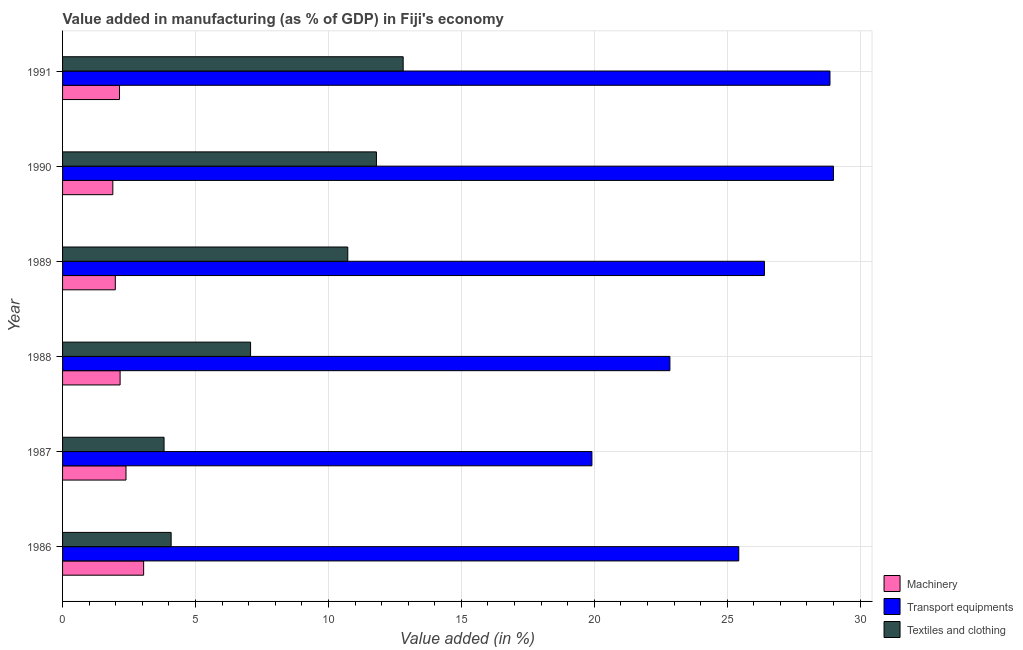Are the number of bars on each tick of the Y-axis equal?
Offer a terse response. Yes. How many bars are there on the 1st tick from the bottom?
Provide a short and direct response. 3. What is the value added in manufacturing transport equipments in 1988?
Your response must be concise. 22.84. Across all years, what is the maximum value added in manufacturing machinery?
Give a very brief answer. 3.05. Across all years, what is the minimum value added in manufacturing textile and clothing?
Ensure brevity in your answer.  3.82. In which year was the value added in manufacturing machinery maximum?
Your answer should be very brief. 1986. What is the total value added in manufacturing transport equipments in the graph?
Your answer should be compact. 152.45. What is the difference between the value added in manufacturing transport equipments in 1987 and that in 1988?
Your response must be concise. -2.93. What is the difference between the value added in manufacturing transport equipments in 1987 and the value added in manufacturing textile and clothing in 1990?
Keep it short and to the point. 8.11. What is the average value added in manufacturing machinery per year?
Your answer should be compact. 2.27. In the year 1987, what is the difference between the value added in manufacturing transport equipments and value added in manufacturing textile and clothing?
Offer a very short reply. 16.09. In how many years, is the value added in manufacturing textile and clothing greater than 3 %?
Give a very brief answer. 6. What is the ratio of the value added in manufacturing machinery in 1986 to that in 1988?
Your answer should be very brief. 1.41. Is the difference between the value added in manufacturing transport equipments in 1988 and 1990 greater than the difference between the value added in manufacturing textile and clothing in 1988 and 1990?
Make the answer very short. No. What is the difference between the highest and the second highest value added in manufacturing machinery?
Ensure brevity in your answer.  0.66. What is the difference between the highest and the lowest value added in manufacturing machinery?
Offer a terse response. 1.16. Is the sum of the value added in manufacturing transport equipments in 1990 and 1991 greater than the maximum value added in manufacturing machinery across all years?
Give a very brief answer. Yes. What does the 2nd bar from the top in 1987 represents?
Make the answer very short. Transport equipments. What does the 3rd bar from the bottom in 1991 represents?
Your answer should be compact. Textiles and clothing. Is it the case that in every year, the sum of the value added in manufacturing machinery and value added in manufacturing transport equipments is greater than the value added in manufacturing textile and clothing?
Your answer should be very brief. Yes. Are all the bars in the graph horizontal?
Give a very brief answer. Yes. How many years are there in the graph?
Keep it short and to the point. 6. Are the values on the major ticks of X-axis written in scientific E-notation?
Offer a terse response. No. Does the graph contain any zero values?
Make the answer very short. No. Does the graph contain grids?
Provide a short and direct response. Yes. Where does the legend appear in the graph?
Make the answer very short. Bottom right. How are the legend labels stacked?
Your answer should be compact. Vertical. What is the title of the graph?
Your response must be concise. Value added in manufacturing (as % of GDP) in Fiji's economy. What is the label or title of the X-axis?
Your response must be concise. Value added (in %). What is the label or title of the Y-axis?
Your response must be concise. Year. What is the Value added (in %) of Machinery in 1986?
Keep it short and to the point. 3.05. What is the Value added (in %) of Transport equipments in 1986?
Offer a terse response. 25.43. What is the Value added (in %) of Textiles and clothing in 1986?
Offer a terse response. 4.08. What is the Value added (in %) of Machinery in 1987?
Your response must be concise. 2.39. What is the Value added (in %) in Transport equipments in 1987?
Ensure brevity in your answer.  19.91. What is the Value added (in %) of Textiles and clothing in 1987?
Your response must be concise. 3.82. What is the Value added (in %) in Machinery in 1988?
Ensure brevity in your answer.  2.16. What is the Value added (in %) in Transport equipments in 1988?
Offer a very short reply. 22.84. What is the Value added (in %) of Textiles and clothing in 1988?
Your answer should be very brief. 7.07. What is the Value added (in %) in Machinery in 1989?
Offer a very short reply. 1.98. What is the Value added (in %) of Transport equipments in 1989?
Provide a succinct answer. 26.4. What is the Value added (in %) in Textiles and clothing in 1989?
Ensure brevity in your answer.  10.73. What is the Value added (in %) of Machinery in 1990?
Your answer should be very brief. 1.89. What is the Value added (in %) in Transport equipments in 1990?
Your answer should be very brief. 29. What is the Value added (in %) in Textiles and clothing in 1990?
Offer a very short reply. 11.81. What is the Value added (in %) in Machinery in 1991?
Your answer should be compact. 2.14. What is the Value added (in %) in Transport equipments in 1991?
Offer a very short reply. 28.86. What is the Value added (in %) in Textiles and clothing in 1991?
Offer a terse response. 12.81. Across all years, what is the maximum Value added (in %) in Machinery?
Provide a succinct answer. 3.05. Across all years, what is the maximum Value added (in %) in Transport equipments?
Make the answer very short. 29. Across all years, what is the maximum Value added (in %) of Textiles and clothing?
Your response must be concise. 12.81. Across all years, what is the minimum Value added (in %) of Machinery?
Provide a succinct answer. 1.89. Across all years, what is the minimum Value added (in %) in Transport equipments?
Your response must be concise. 19.91. Across all years, what is the minimum Value added (in %) of Textiles and clothing?
Your response must be concise. 3.82. What is the total Value added (in %) in Machinery in the graph?
Ensure brevity in your answer.  13.62. What is the total Value added (in %) of Transport equipments in the graph?
Make the answer very short. 152.45. What is the total Value added (in %) in Textiles and clothing in the graph?
Your answer should be very brief. 50.32. What is the difference between the Value added (in %) of Machinery in 1986 and that in 1987?
Provide a succinct answer. 0.66. What is the difference between the Value added (in %) of Transport equipments in 1986 and that in 1987?
Your answer should be compact. 5.52. What is the difference between the Value added (in %) of Textiles and clothing in 1986 and that in 1987?
Keep it short and to the point. 0.27. What is the difference between the Value added (in %) in Machinery in 1986 and that in 1988?
Make the answer very short. 0.89. What is the difference between the Value added (in %) in Transport equipments in 1986 and that in 1988?
Offer a very short reply. 2.59. What is the difference between the Value added (in %) in Textiles and clothing in 1986 and that in 1988?
Provide a short and direct response. -2.99. What is the difference between the Value added (in %) of Machinery in 1986 and that in 1989?
Offer a very short reply. 1.07. What is the difference between the Value added (in %) of Transport equipments in 1986 and that in 1989?
Offer a very short reply. -0.97. What is the difference between the Value added (in %) in Textiles and clothing in 1986 and that in 1989?
Give a very brief answer. -6.64. What is the difference between the Value added (in %) in Machinery in 1986 and that in 1990?
Ensure brevity in your answer.  1.16. What is the difference between the Value added (in %) in Transport equipments in 1986 and that in 1990?
Provide a succinct answer. -3.56. What is the difference between the Value added (in %) in Textiles and clothing in 1986 and that in 1990?
Offer a terse response. -7.72. What is the difference between the Value added (in %) in Machinery in 1986 and that in 1991?
Offer a terse response. 0.91. What is the difference between the Value added (in %) of Transport equipments in 1986 and that in 1991?
Your response must be concise. -3.43. What is the difference between the Value added (in %) in Textiles and clothing in 1986 and that in 1991?
Ensure brevity in your answer.  -8.73. What is the difference between the Value added (in %) of Machinery in 1987 and that in 1988?
Your response must be concise. 0.22. What is the difference between the Value added (in %) of Transport equipments in 1987 and that in 1988?
Give a very brief answer. -2.93. What is the difference between the Value added (in %) in Textiles and clothing in 1987 and that in 1988?
Ensure brevity in your answer.  -3.25. What is the difference between the Value added (in %) in Machinery in 1987 and that in 1989?
Offer a very short reply. 0.4. What is the difference between the Value added (in %) of Transport equipments in 1987 and that in 1989?
Give a very brief answer. -6.49. What is the difference between the Value added (in %) of Textiles and clothing in 1987 and that in 1989?
Your answer should be compact. -6.91. What is the difference between the Value added (in %) in Machinery in 1987 and that in 1990?
Provide a short and direct response. 0.5. What is the difference between the Value added (in %) in Transport equipments in 1987 and that in 1990?
Offer a very short reply. -9.09. What is the difference between the Value added (in %) in Textiles and clothing in 1987 and that in 1990?
Make the answer very short. -7.99. What is the difference between the Value added (in %) of Machinery in 1987 and that in 1991?
Give a very brief answer. 0.24. What is the difference between the Value added (in %) in Transport equipments in 1987 and that in 1991?
Your response must be concise. -8.95. What is the difference between the Value added (in %) of Textiles and clothing in 1987 and that in 1991?
Ensure brevity in your answer.  -8.99. What is the difference between the Value added (in %) in Machinery in 1988 and that in 1989?
Keep it short and to the point. 0.18. What is the difference between the Value added (in %) of Transport equipments in 1988 and that in 1989?
Your answer should be very brief. -3.56. What is the difference between the Value added (in %) in Textiles and clothing in 1988 and that in 1989?
Keep it short and to the point. -3.66. What is the difference between the Value added (in %) in Machinery in 1988 and that in 1990?
Keep it short and to the point. 0.27. What is the difference between the Value added (in %) in Transport equipments in 1988 and that in 1990?
Provide a succinct answer. -6.15. What is the difference between the Value added (in %) in Textiles and clothing in 1988 and that in 1990?
Your response must be concise. -4.73. What is the difference between the Value added (in %) of Machinery in 1988 and that in 1991?
Ensure brevity in your answer.  0.02. What is the difference between the Value added (in %) of Transport equipments in 1988 and that in 1991?
Provide a succinct answer. -6.02. What is the difference between the Value added (in %) of Textiles and clothing in 1988 and that in 1991?
Your response must be concise. -5.74. What is the difference between the Value added (in %) in Machinery in 1989 and that in 1990?
Ensure brevity in your answer.  0.09. What is the difference between the Value added (in %) in Transport equipments in 1989 and that in 1990?
Make the answer very short. -2.6. What is the difference between the Value added (in %) of Textiles and clothing in 1989 and that in 1990?
Give a very brief answer. -1.08. What is the difference between the Value added (in %) in Machinery in 1989 and that in 1991?
Offer a very short reply. -0.16. What is the difference between the Value added (in %) of Transport equipments in 1989 and that in 1991?
Ensure brevity in your answer.  -2.46. What is the difference between the Value added (in %) of Textiles and clothing in 1989 and that in 1991?
Provide a succinct answer. -2.08. What is the difference between the Value added (in %) of Machinery in 1990 and that in 1991?
Give a very brief answer. -0.25. What is the difference between the Value added (in %) of Transport equipments in 1990 and that in 1991?
Make the answer very short. 0.13. What is the difference between the Value added (in %) in Textiles and clothing in 1990 and that in 1991?
Ensure brevity in your answer.  -1.01. What is the difference between the Value added (in %) in Machinery in 1986 and the Value added (in %) in Transport equipments in 1987?
Offer a terse response. -16.86. What is the difference between the Value added (in %) of Machinery in 1986 and the Value added (in %) of Textiles and clothing in 1987?
Your response must be concise. -0.77. What is the difference between the Value added (in %) of Transport equipments in 1986 and the Value added (in %) of Textiles and clothing in 1987?
Offer a terse response. 21.62. What is the difference between the Value added (in %) in Machinery in 1986 and the Value added (in %) in Transport equipments in 1988?
Offer a very short reply. -19.79. What is the difference between the Value added (in %) in Machinery in 1986 and the Value added (in %) in Textiles and clothing in 1988?
Offer a terse response. -4.02. What is the difference between the Value added (in %) in Transport equipments in 1986 and the Value added (in %) in Textiles and clothing in 1988?
Give a very brief answer. 18.36. What is the difference between the Value added (in %) of Machinery in 1986 and the Value added (in %) of Transport equipments in 1989?
Your answer should be very brief. -23.35. What is the difference between the Value added (in %) of Machinery in 1986 and the Value added (in %) of Textiles and clothing in 1989?
Give a very brief answer. -7.68. What is the difference between the Value added (in %) in Transport equipments in 1986 and the Value added (in %) in Textiles and clothing in 1989?
Offer a terse response. 14.71. What is the difference between the Value added (in %) in Machinery in 1986 and the Value added (in %) in Transport equipments in 1990?
Your answer should be very brief. -25.95. What is the difference between the Value added (in %) of Machinery in 1986 and the Value added (in %) of Textiles and clothing in 1990?
Offer a terse response. -8.76. What is the difference between the Value added (in %) in Transport equipments in 1986 and the Value added (in %) in Textiles and clothing in 1990?
Offer a very short reply. 13.63. What is the difference between the Value added (in %) of Machinery in 1986 and the Value added (in %) of Transport equipments in 1991?
Provide a succinct answer. -25.82. What is the difference between the Value added (in %) in Machinery in 1986 and the Value added (in %) in Textiles and clothing in 1991?
Ensure brevity in your answer.  -9.76. What is the difference between the Value added (in %) of Transport equipments in 1986 and the Value added (in %) of Textiles and clothing in 1991?
Give a very brief answer. 12.62. What is the difference between the Value added (in %) in Machinery in 1987 and the Value added (in %) in Transport equipments in 1988?
Make the answer very short. -20.46. What is the difference between the Value added (in %) of Machinery in 1987 and the Value added (in %) of Textiles and clothing in 1988?
Make the answer very short. -4.69. What is the difference between the Value added (in %) of Transport equipments in 1987 and the Value added (in %) of Textiles and clothing in 1988?
Provide a short and direct response. 12.84. What is the difference between the Value added (in %) of Machinery in 1987 and the Value added (in %) of Transport equipments in 1989?
Make the answer very short. -24.01. What is the difference between the Value added (in %) of Machinery in 1987 and the Value added (in %) of Textiles and clothing in 1989?
Give a very brief answer. -8.34. What is the difference between the Value added (in %) in Transport equipments in 1987 and the Value added (in %) in Textiles and clothing in 1989?
Ensure brevity in your answer.  9.18. What is the difference between the Value added (in %) of Machinery in 1987 and the Value added (in %) of Transport equipments in 1990?
Offer a terse response. -26.61. What is the difference between the Value added (in %) of Machinery in 1987 and the Value added (in %) of Textiles and clothing in 1990?
Offer a terse response. -9.42. What is the difference between the Value added (in %) of Transport equipments in 1987 and the Value added (in %) of Textiles and clothing in 1990?
Ensure brevity in your answer.  8.11. What is the difference between the Value added (in %) of Machinery in 1987 and the Value added (in %) of Transport equipments in 1991?
Offer a very short reply. -26.48. What is the difference between the Value added (in %) of Machinery in 1987 and the Value added (in %) of Textiles and clothing in 1991?
Provide a short and direct response. -10.43. What is the difference between the Value added (in %) of Transport equipments in 1987 and the Value added (in %) of Textiles and clothing in 1991?
Your answer should be compact. 7.1. What is the difference between the Value added (in %) of Machinery in 1988 and the Value added (in %) of Transport equipments in 1989?
Your response must be concise. -24.24. What is the difference between the Value added (in %) in Machinery in 1988 and the Value added (in %) in Textiles and clothing in 1989?
Offer a terse response. -8.56. What is the difference between the Value added (in %) of Transport equipments in 1988 and the Value added (in %) of Textiles and clothing in 1989?
Offer a very short reply. 12.12. What is the difference between the Value added (in %) of Machinery in 1988 and the Value added (in %) of Transport equipments in 1990?
Ensure brevity in your answer.  -26.83. What is the difference between the Value added (in %) in Machinery in 1988 and the Value added (in %) in Textiles and clothing in 1990?
Ensure brevity in your answer.  -9.64. What is the difference between the Value added (in %) in Transport equipments in 1988 and the Value added (in %) in Textiles and clothing in 1990?
Give a very brief answer. 11.04. What is the difference between the Value added (in %) in Machinery in 1988 and the Value added (in %) in Transport equipments in 1991?
Make the answer very short. -26.7. What is the difference between the Value added (in %) in Machinery in 1988 and the Value added (in %) in Textiles and clothing in 1991?
Provide a succinct answer. -10.65. What is the difference between the Value added (in %) in Transport equipments in 1988 and the Value added (in %) in Textiles and clothing in 1991?
Offer a terse response. 10.03. What is the difference between the Value added (in %) of Machinery in 1989 and the Value added (in %) of Transport equipments in 1990?
Provide a short and direct response. -27.01. What is the difference between the Value added (in %) in Machinery in 1989 and the Value added (in %) in Textiles and clothing in 1990?
Make the answer very short. -9.82. What is the difference between the Value added (in %) of Transport equipments in 1989 and the Value added (in %) of Textiles and clothing in 1990?
Ensure brevity in your answer.  14.59. What is the difference between the Value added (in %) of Machinery in 1989 and the Value added (in %) of Transport equipments in 1991?
Provide a short and direct response. -26.88. What is the difference between the Value added (in %) of Machinery in 1989 and the Value added (in %) of Textiles and clothing in 1991?
Provide a succinct answer. -10.83. What is the difference between the Value added (in %) in Transport equipments in 1989 and the Value added (in %) in Textiles and clothing in 1991?
Your answer should be compact. 13.59. What is the difference between the Value added (in %) of Machinery in 1990 and the Value added (in %) of Transport equipments in 1991?
Your answer should be very brief. -26.97. What is the difference between the Value added (in %) in Machinery in 1990 and the Value added (in %) in Textiles and clothing in 1991?
Your response must be concise. -10.92. What is the difference between the Value added (in %) in Transport equipments in 1990 and the Value added (in %) in Textiles and clothing in 1991?
Your answer should be compact. 16.19. What is the average Value added (in %) of Machinery per year?
Offer a very short reply. 2.27. What is the average Value added (in %) in Transport equipments per year?
Offer a very short reply. 25.41. What is the average Value added (in %) of Textiles and clothing per year?
Make the answer very short. 8.39. In the year 1986, what is the difference between the Value added (in %) of Machinery and Value added (in %) of Transport equipments?
Your response must be concise. -22.38. In the year 1986, what is the difference between the Value added (in %) in Machinery and Value added (in %) in Textiles and clothing?
Provide a short and direct response. -1.03. In the year 1986, what is the difference between the Value added (in %) in Transport equipments and Value added (in %) in Textiles and clothing?
Ensure brevity in your answer.  21.35. In the year 1987, what is the difference between the Value added (in %) in Machinery and Value added (in %) in Transport equipments?
Provide a succinct answer. -17.53. In the year 1987, what is the difference between the Value added (in %) of Machinery and Value added (in %) of Textiles and clothing?
Your response must be concise. -1.43. In the year 1987, what is the difference between the Value added (in %) in Transport equipments and Value added (in %) in Textiles and clothing?
Your response must be concise. 16.09. In the year 1988, what is the difference between the Value added (in %) of Machinery and Value added (in %) of Transport equipments?
Provide a short and direct response. -20.68. In the year 1988, what is the difference between the Value added (in %) of Machinery and Value added (in %) of Textiles and clothing?
Offer a terse response. -4.91. In the year 1988, what is the difference between the Value added (in %) of Transport equipments and Value added (in %) of Textiles and clothing?
Give a very brief answer. 15.77. In the year 1989, what is the difference between the Value added (in %) in Machinery and Value added (in %) in Transport equipments?
Give a very brief answer. -24.42. In the year 1989, what is the difference between the Value added (in %) of Machinery and Value added (in %) of Textiles and clothing?
Your answer should be compact. -8.74. In the year 1989, what is the difference between the Value added (in %) in Transport equipments and Value added (in %) in Textiles and clothing?
Provide a succinct answer. 15.67. In the year 1990, what is the difference between the Value added (in %) of Machinery and Value added (in %) of Transport equipments?
Provide a succinct answer. -27.11. In the year 1990, what is the difference between the Value added (in %) of Machinery and Value added (in %) of Textiles and clothing?
Provide a short and direct response. -9.92. In the year 1990, what is the difference between the Value added (in %) in Transport equipments and Value added (in %) in Textiles and clothing?
Provide a short and direct response. 17.19. In the year 1991, what is the difference between the Value added (in %) of Machinery and Value added (in %) of Transport equipments?
Provide a short and direct response. -26.72. In the year 1991, what is the difference between the Value added (in %) of Machinery and Value added (in %) of Textiles and clothing?
Offer a very short reply. -10.67. In the year 1991, what is the difference between the Value added (in %) in Transport equipments and Value added (in %) in Textiles and clothing?
Offer a very short reply. 16.05. What is the ratio of the Value added (in %) in Machinery in 1986 to that in 1987?
Give a very brief answer. 1.28. What is the ratio of the Value added (in %) of Transport equipments in 1986 to that in 1987?
Your response must be concise. 1.28. What is the ratio of the Value added (in %) of Textiles and clothing in 1986 to that in 1987?
Provide a short and direct response. 1.07. What is the ratio of the Value added (in %) in Machinery in 1986 to that in 1988?
Your answer should be compact. 1.41. What is the ratio of the Value added (in %) in Transport equipments in 1986 to that in 1988?
Your response must be concise. 1.11. What is the ratio of the Value added (in %) in Textiles and clothing in 1986 to that in 1988?
Make the answer very short. 0.58. What is the ratio of the Value added (in %) in Machinery in 1986 to that in 1989?
Your answer should be compact. 1.54. What is the ratio of the Value added (in %) in Transport equipments in 1986 to that in 1989?
Provide a succinct answer. 0.96. What is the ratio of the Value added (in %) in Textiles and clothing in 1986 to that in 1989?
Provide a short and direct response. 0.38. What is the ratio of the Value added (in %) in Machinery in 1986 to that in 1990?
Give a very brief answer. 1.61. What is the ratio of the Value added (in %) of Transport equipments in 1986 to that in 1990?
Offer a terse response. 0.88. What is the ratio of the Value added (in %) in Textiles and clothing in 1986 to that in 1990?
Ensure brevity in your answer.  0.35. What is the ratio of the Value added (in %) in Machinery in 1986 to that in 1991?
Give a very brief answer. 1.42. What is the ratio of the Value added (in %) in Transport equipments in 1986 to that in 1991?
Your answer should be compact. 0.88. What is the ratio of the Value added (in %) of Textiles and clothing in 1986 to that in 1991?
Your answer should be compact. 0.32. What is the ratio of the Value added (in %) in Machinery in 1987 to that in 1988?
Your answer should be compact. 1.1. What is the ratio of the Value added (in %) of Transport equipments in 1987 to that in 1988?
Make the answer very short. 0.87. What is the ratio of the Value added (in %) in Textiles and clothing in 1987 to that in 1988?
Offer a very short reply. 0.54. What is the ratio of the Value added (in %) in Machinery in 1987 to that in 1989?
Your response must be concise. 1.2. What is the ratio of the Value added (in %) of Transport equipments in 1987 to that in 1989?
Provide a short and direct response. 0.75. What is the ratio of the Value added (in %) in Textiles and clothing in 1987 to that in 1989?
Provide a short and direct response. 0.36. What is the ratio of the Value added (in %) in Machinery in 1987 to that in 1990?
Keep it short and to the point. 1.26. What is the ratio of the Value added (in %) in Transport equipments in 1987 to that in 1990?
Ensure brevity in your answer.  0.69. What is the ratio of the Value added (in %) in Textiles and clothing in 1987 to that in 1990?
Your answer should be compact. 0.32. What is the ratio of the Value added (in %) in Machinery in 1987 to that in 1991?
Keep it short and to the point. 1.11. What is the ratio of the Value added (in %) of Transport equipments in 1987 to that in 1991?
Your answer should be very brief. 0.69. What is the ratio of the Value added (in %) of Textiles and clothing in 1987 to that in 1991?
Give a very brief answer. 0.3. What is the ratio of the Value added (in %) in Machinery in 1988 to that in 1989?
Offer a terse response. 1.09. What is the ratio of the Value added (in %) of Transport equipments in 1988 to that in 1989?
Offer a terse response. 0.87. What is the ratio of the Value added (in %) of Textiles and clothing in 1988 to that in 1989?
Give a very brief answer. 0.66. What is the ratio of the Value added (in %) in Machinery in 1988 to that in 1990?
Give a very brief answer. 1.14. What is the ratio of the Value added (in %) of Transport equipments in 1988 to that in 1990?
Offer a very short reply. 0.79. What is the ratio of the Value added (in %) in Textiles and clothing in 1988 to that in 1990?
Your answer should be compact. 0.6. What is the ratio of the Value added (in %) in Machinery in 1988 to that in 1991?
Keep it short and to the point. 1.01. What is the ratio of the Value added (in %) in Transport equipments in 1988 to that in 1991?
Ensure brevity in your answer.  0.79. What is the ratio of the Value added (in %) of Textiles and clothing in 1988 to that in 1991?
Keep it short and to the point. 0.55. What is the ratio of the Value added (in %) of Machinery in 1989 to that in 1990?
Your response must be concise. 1.05. What is the ratio of the Value added (in %) of Transport equipments in 1989 to that in 1990?
Make the answer very short. 0.91. What is the ratio of the Value added (in %) in Textiles and clothing in 1989 to that in 1990?
Provide a short and direct response. 0.91. What is the ratio of the Value added (in %) of Machinery in 1989 to that in 1991?
Ensure brevity in your answer.  0.93. What is the ratio of the Value added (in %) in Transport equipments in 1989 to that in 1991?
Give a very brief answer. 0.91. What is the ratio of the Value added (in %) in Textiles and clothing in 1989 to that in 1991?
Keep it short and to the point. 0.84. What is the ratio of the Value added (in %) of Machinery in 1990 to that in 1991?
Keep it short and to the point. 0.88. What is the ratio of the Value added (in %) in Textiles and clothing in 1990 to that in 1991?
Provide a succinct answer. 0.92. What is the difference between the highest and the second highest Value added (in %) of Machinery?
Offer a terse response. 0.66. What is the difference between the highest and the second highest Value added (in %) in Transport equipments?
Give a very brief answer. 0.13. What is the difference between the highest and the lowest Value added (in %) of Machinery?
Ensure brevity in your answer.  1.16. What is the difference between the highest and the lowest Value added (in %) of Transport equipments?
Provide a succinct answer. 9.09. What is the difference between the highest and the lowest Value added (in %) in Textiles and clothing?
Provide a short and direct response. 8.99. 